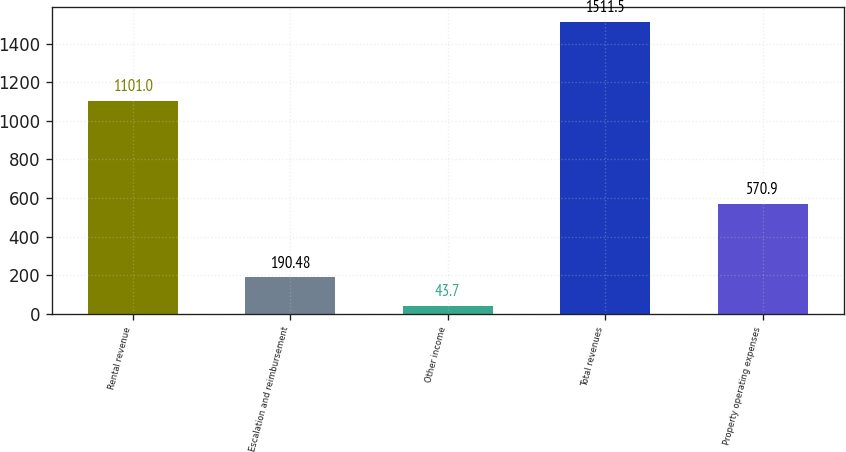Convert chart. <chart><loc_0><loc_0><loc_500><loc_500><bar_chart><fcel>Rental revenue<fcel>Escalation and reimbursement<fcel>Other income<fcel>Total revenues<fcel>Property operating expenses<nl><fcel>1101<fcel>190.48<fcel>43.7<fcel>1511.5<fcel>570.9<nl></chart> 